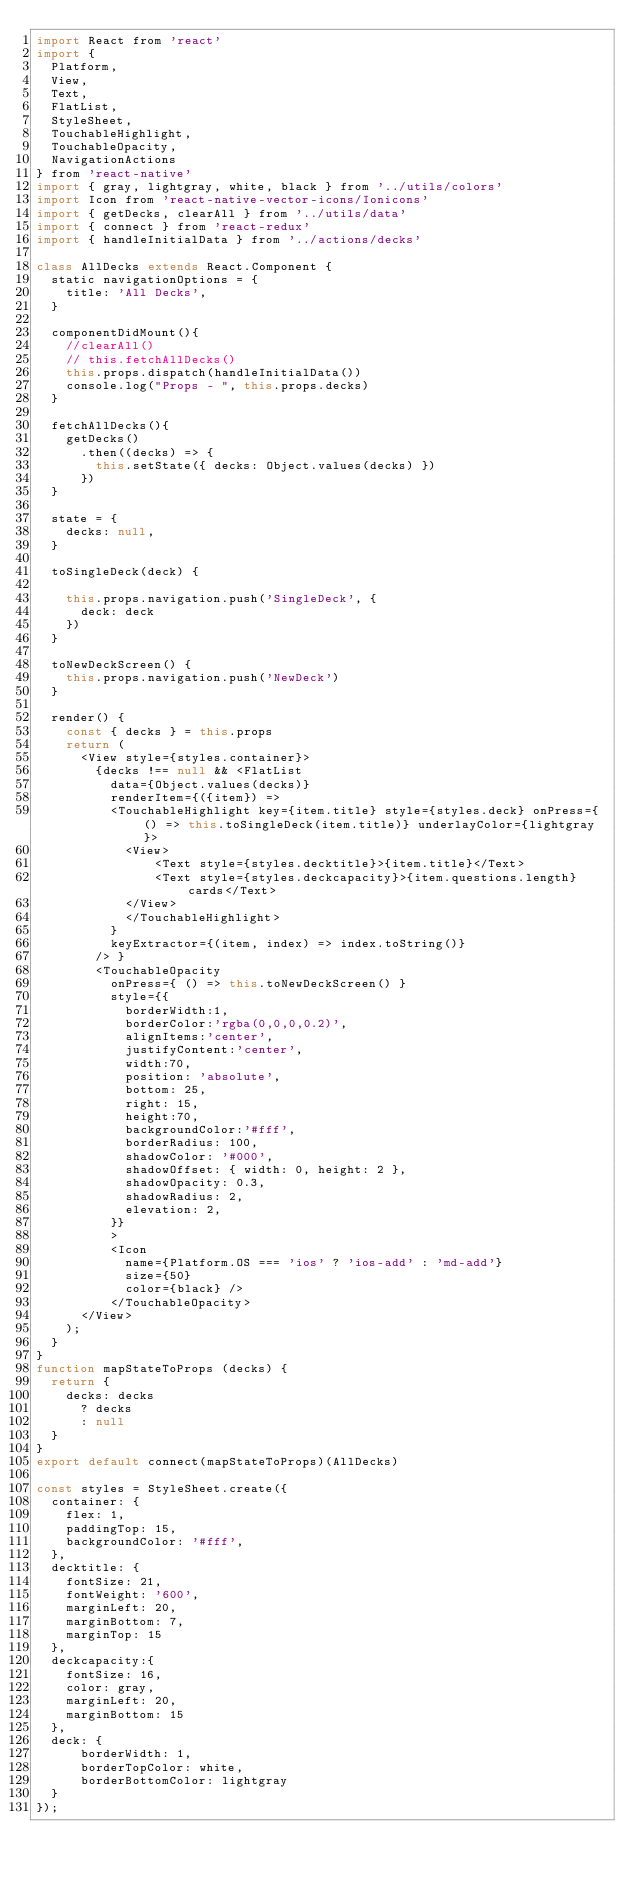Convert code to text. <code><loc_0><loc_0><loc_500><loc_500><_JavaScript_>import React from 'react'
import { 
  Platform, 
  View, 
  Text, 
  FlatList, 
  StyleSheet, 
  TouchableHighlight, 
  TouchableOpacity,
  NavigationActions
} from 'react-native'
import { gray, lightgray, white, black } from '../utils/colors'
import Icon from 'react-native-vector-icons/Ionicons'
import { getDecks, clearAll } from '../utils/data'
import { connect } from 'react-redux'
import { handleInitialData } from '../actions/decks'

class AllDecks extends React.Component {
  static navigationOptions = {
    title: 'All Decks',
  }

  componentDidMount(){
    //clearAll()
    // this.fetchAllDecks()
    this.props.dispatch(handleInitialData())
    console.log("Props - ", this.props.decks)
  }

  fetchAllDecks(){
    getDecks()
      .then((decks) => {
        this.setState({ decks: Object.values(decks) })
      })
  }

  state = {
    decks: null,
  }

  toSingleDeck(deck) {

    this.props.navigation.push('SingleDeck', {
      deck: deck
    })
  }

  toNewDeckScreen() {
    this.props.navigation.push('NewDeck')
  }

  render() {
    const { decks } = this.props
    return (
      <View style={styles.container}>
        {decks !== null && <FlatList 
          data={Object.values(decks)}  
          renderItem={({item}) =>
          <TouchableHighlight key={item.title} style={styles.deck} onPress={ () => this.toSingleDeck(item.title)} underlayColor={lightgray}>
            <View>
                <Text style={styles.decktitle}>{item.title}</Text>
                <Text style={styles.deckcapacity}>{item.questions.length} cards</Text>          
            </View>
            </TouchableHighlight>
          }
          keyExtractor={(item, index) => index.toString()}
        /> }
        <TouchableOpacity
          onPress={ () => this.toNewDeckScreen() }
          style={{
            borderWidth:1,
            borderColor:'rgba(0,0,0,0.2)',
            alignItems:'center',
            justifyContent:'center',
            width:70,
            position: 'absolute',                                          
            bottom: 25,                                                    
            right: 15,
            height:70,
            backgroundColor:'#fff',
            borderRadius: 100,
            shadowColor: '#000',
            shadowOffset: { width: 0, height: 2 },
            shadowOpacity: 0.3,
            shadowRadius: 2,
            elevation: 2,
          }}
          >
          <Icon 
            name={Platform.OS === 'ios' ? 'ios-add' : 'md-add'} 
            size={50} 
            color={black} />
          </TouchableOpacity>
      </View>
    );
  }
}
function mapStateToProps (decks) {
  return { 
    decks: decks
      ? decks
      : null
  }
}
export default connect(mapStateToProps)(AllDecks)

const styles = StyleSheet.create({
  container: {
    flex: 1,
    paddingTop: 15,
    backgroundColor: '#fff',
  },
  decktitle: {
    fontSize: 21,
    fontWeight: '600',
    marginLeft: 20,
    marginBottom: 7,
    marginTop: 15
  },
  deckcapacity:{
    fontSize: 16,
    color: gray,
    marginLeft: 20,
    marginBottom: 15
  },
  deck: {
      borderWidth: 1,
      borderTopColor: white,
      borderBottomColor: lightgray
  }
});
</code> 